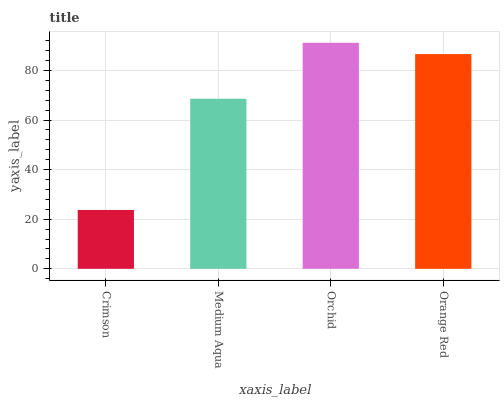Is Crimson the minimum?
Answer yes or no. Yes. Is Orchid the maximum?
Answer yes or no. Yes. Is Medium Aqua the minimum?
Answer yes or no. No. Is Medium Aqua the maximum?
Answer yes or no. No. Is Medium Aqua greater than Crimson?
Answer yes or no. Yes. Is Crimson less than Medium Aqua?
Answer yes or no. Yes. Is Crimson greater than Medium Aqua?
Answer yes or no. No. Is Medium Aqua less than Crimson?
Answer yes or no. No. Is Orange Red the high median?
Answer yes or no. Yes. Is Medium Aqua the low median?
Answer yes or no. Yes. Is Crimson the high median?
Answer yes or no. No. Is Crimson the low median?
Answer yes or no. No. 